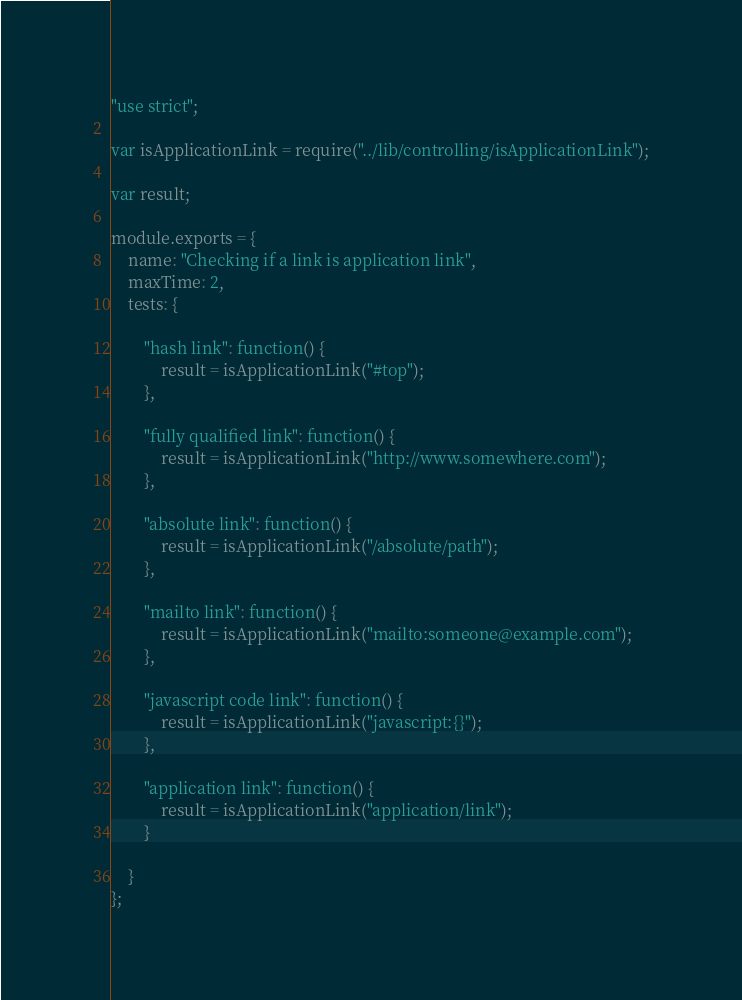Convert code to text. <code><loc_0><loc_0><loc_500><loc_500><_JavaScript_>"use strict";

var isApplicationLink = require("../lib/controlling/isApplicationLink");

var result;

module.exports = {
    name: "Checking if a link is application link",
    maxTime: 2,
    tests: {

        "hash link": function() {
            result = isApplicationLink("#top");
        },

        "fully qualified link": function() {
            result = isApplicationLink("http://www.somewhere.com");
        },

        "absolute link": function() {
            result = isApplicationLink("/absolute/path");
        },

        "mailto link": function() {
            result = isApplicationLink("mailto:someone@example.com");
        },

        "javascript code link": function() {
            result = isApplicationLink("javascript:{}");
        },

        "application link": function() {
            result = isApplicationLink("application/link");
        }

    }
};
</code> 